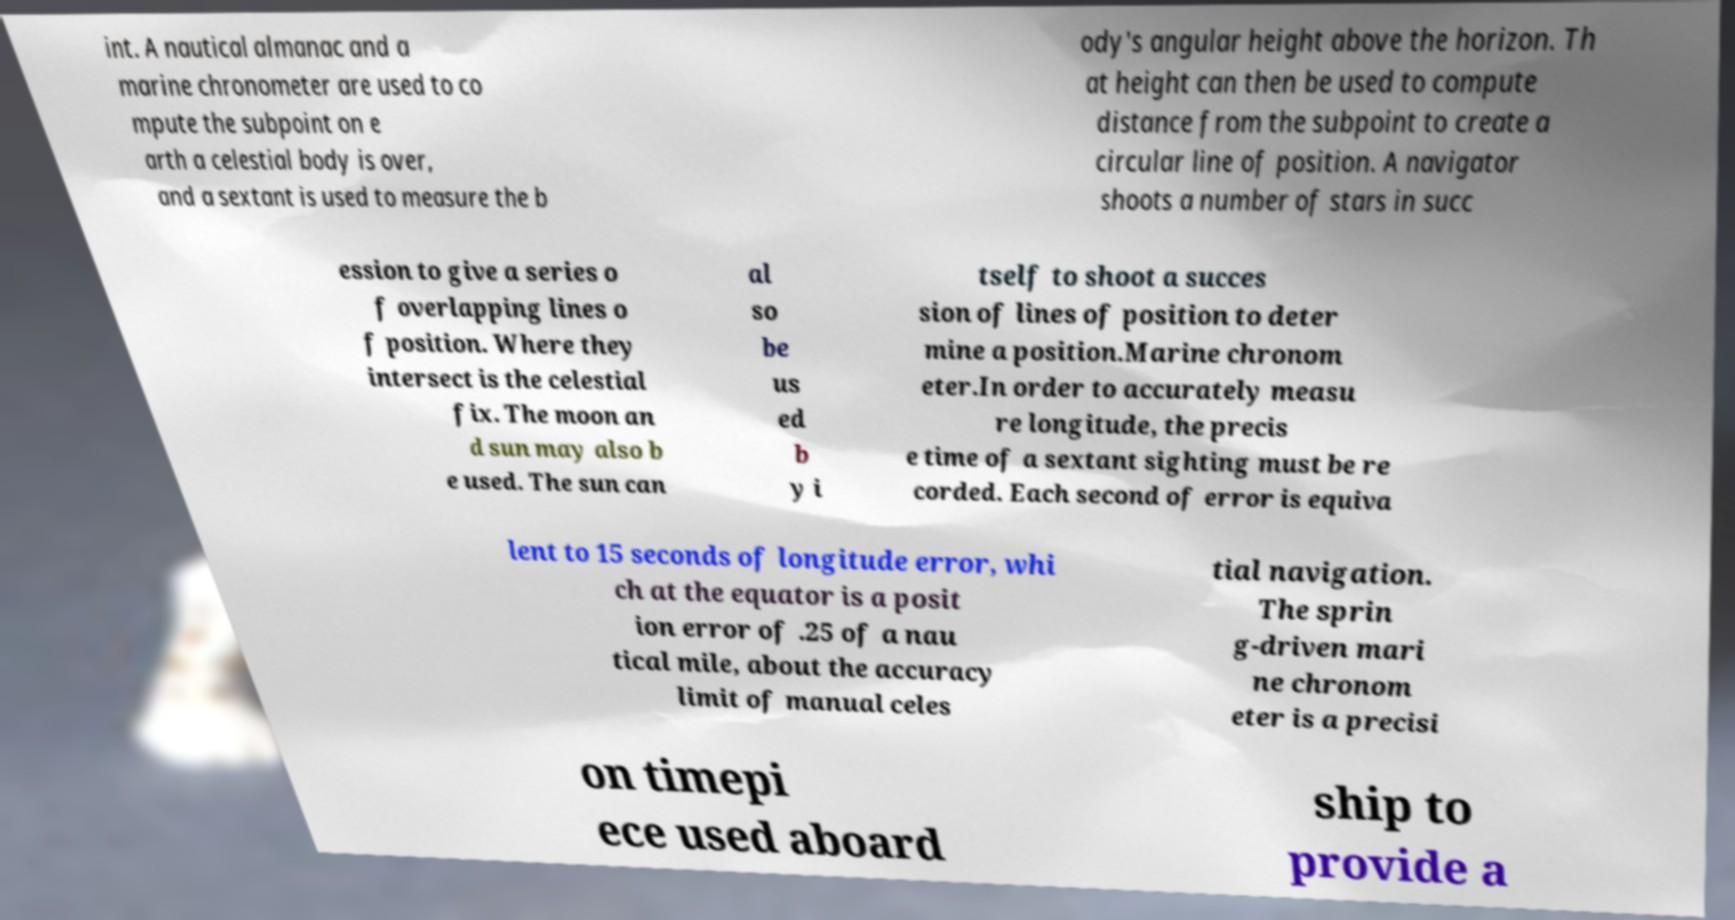Could you extract and type out the text from this image? int. A nautical almanac and a marine chronometer are used to co mpute the subpoint on e arth a celestial body is over, and a sextant is used to measure the b ody's angular height above the horizon. Th at height can then be used to compute distance from the subpoint to create a circular line of position. A navigator shoots a number of stars in succ ession to give a series o f overlapping lines o f position. Where they intersect is the celestial fix. The moon an d sun may also b e used. The sun can al so be us ed b y i tself to shoot a succes sion of lines of position to deter mine a position.Marine chronom eter.In order to accurately measu re longitude, the precis e time of a sextant sighting must be re corded. Each second of error is equiva lent to 15 seconds of longitude error, whi ch at the equator is a posit ion error of .25 of a nau tical mile, about the accuracy limit of manual celes tial navigation. The sprin g-driven mari ne chronom eter is a precisi on timepi ece used aboard ship to provide a 